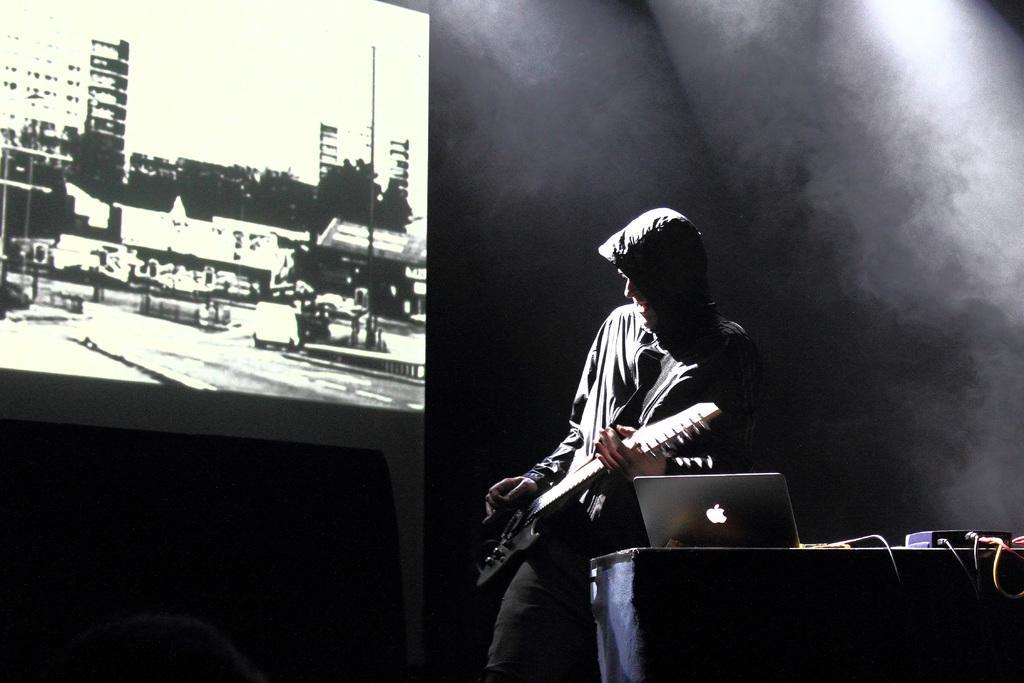Describe this image in one or two sentences. Man is playing the guitar there is a laptop beside of him and a projected image on the left. 